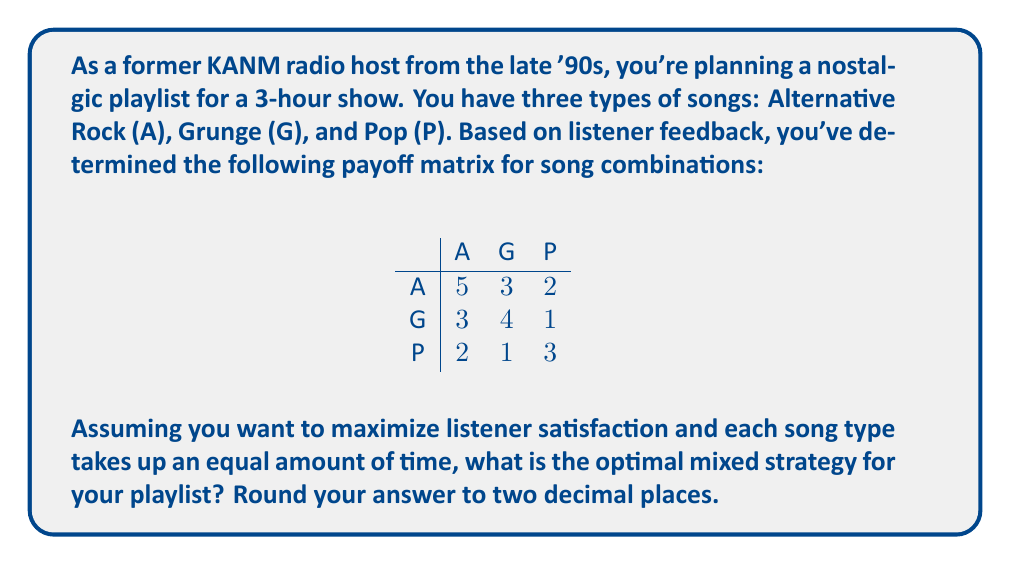Help me with this question. To solve this problem, we'll use the concept of mixed strategy Nash equilibrium in game theory. Here's the step-by-step solution:

1) First, let's define our variables:
   Let $x$ = probability of playing Alternative Rock
   Let $y$ = probability of playing Grunge
   Let $z$ = probability of playing Pop

2) We know that $x + y + z = 1$ since these probabilities must sum to 1.

3) In a mixed strategy equilibrium, the expected payoff for each pure strategy should be equal. Let's call this expected payoff $E$. We can set up three equations:

   For Alternative Rock: $5x + 3y + 2z = E$
   For Grunge: $3x + 4y + z = E$
   For Pop: $2x + y + 3z = E$

4) We can solve this system of equations along with $x + y + z = 1$:

   $5x + 3y + 2z = 3x + 4y + z$
   $2x - y + z = 0$ ... (Equation 1)

   $5x + 3y + 2z = 2x + y + 3z$
   $3x + 2y - z = 0$ ... (Equation 2)

5) From Equation 1: $z = y - 2x$
   Substituting into Equation 2:
   $3x + 2y - (y - 2x) = 0$
   $5x + y = 0$
   $y = -5x$ ... (Equation 3)

6) Now, using $x + y + z = 1$ and substituting Equations 3 and 1:
   $x + (-5x) + ((-5x) - 2x) = 1$
   $x - 5x - 5x - 2x = 1$
   $-11x = 1$
   $x = -\frac{1}{11}$

7) From Equation 3: $y = -5(-\frac{1}{11}) = \frac{5}{11}$

8) And $z = 1 - x - y = 1 - (-\frac{1}{11}) - \frac{5}{11} = \frac{7}{11}$

9) However, probabilities can't be negative, so we need to adjust our strategy. The negative value for $x$ suggests we should not play Alternative Rock at all.

10) We can now solve a simpler 2x2 game between Grunge and Pop:

    $$
    \begin{array}{c|cc}
     & \text{G} & \text{P} \\
    \hline
    \text{G} & 4 & 1 \\
    \text{P} & 1 & 3
    \end{array}
    $$

11) Let $p$ be the probability of playing Grunge. Then:
    $4p + 1(1-p) = 1p + 3(1-p)$
    $4p + 1 - p = p + 3 - 3p$
    $3p - 1 = -2p + 3$
    $5p = 4$
    $p = \frac{4}{5} = 0.8$

Therefore, the optimal strategy is to play Grunge 80% of the time and Pop 20% of the time.
Answer: (0.00, 0.80, 0.20) 